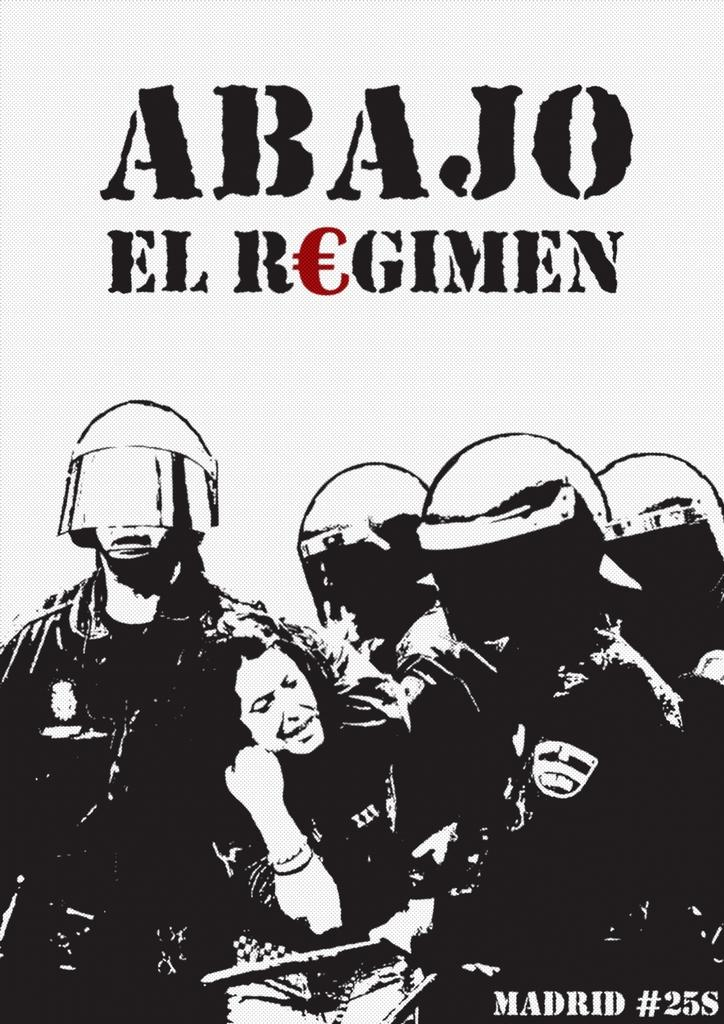What type of visual is depicted in the image? The image appears to be a poster. Has the image been altered in any way? Yes, the image has been edited. Can you describe the people at the bottom of the image? There are men and women at the bottom of the image, and the men are wearing helmets. What can be found at the top of the image? There is text at the top of the image. What type of nut is being used to gain the attention of the mother in the image? There is no nut or mother present in the image; it features a poster with edited images of men and women wearing helmets, along with text at the top. 